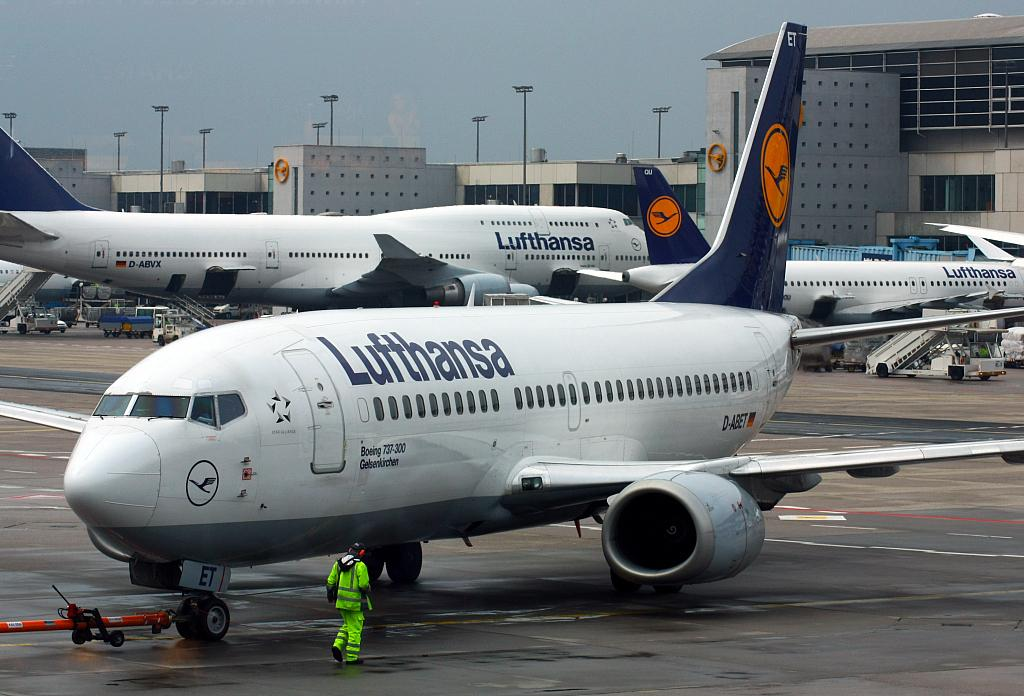<image>
Write a terse but informative summary of the picture. A ground crew worker is walking by the white and blue Lufthansa plane. 